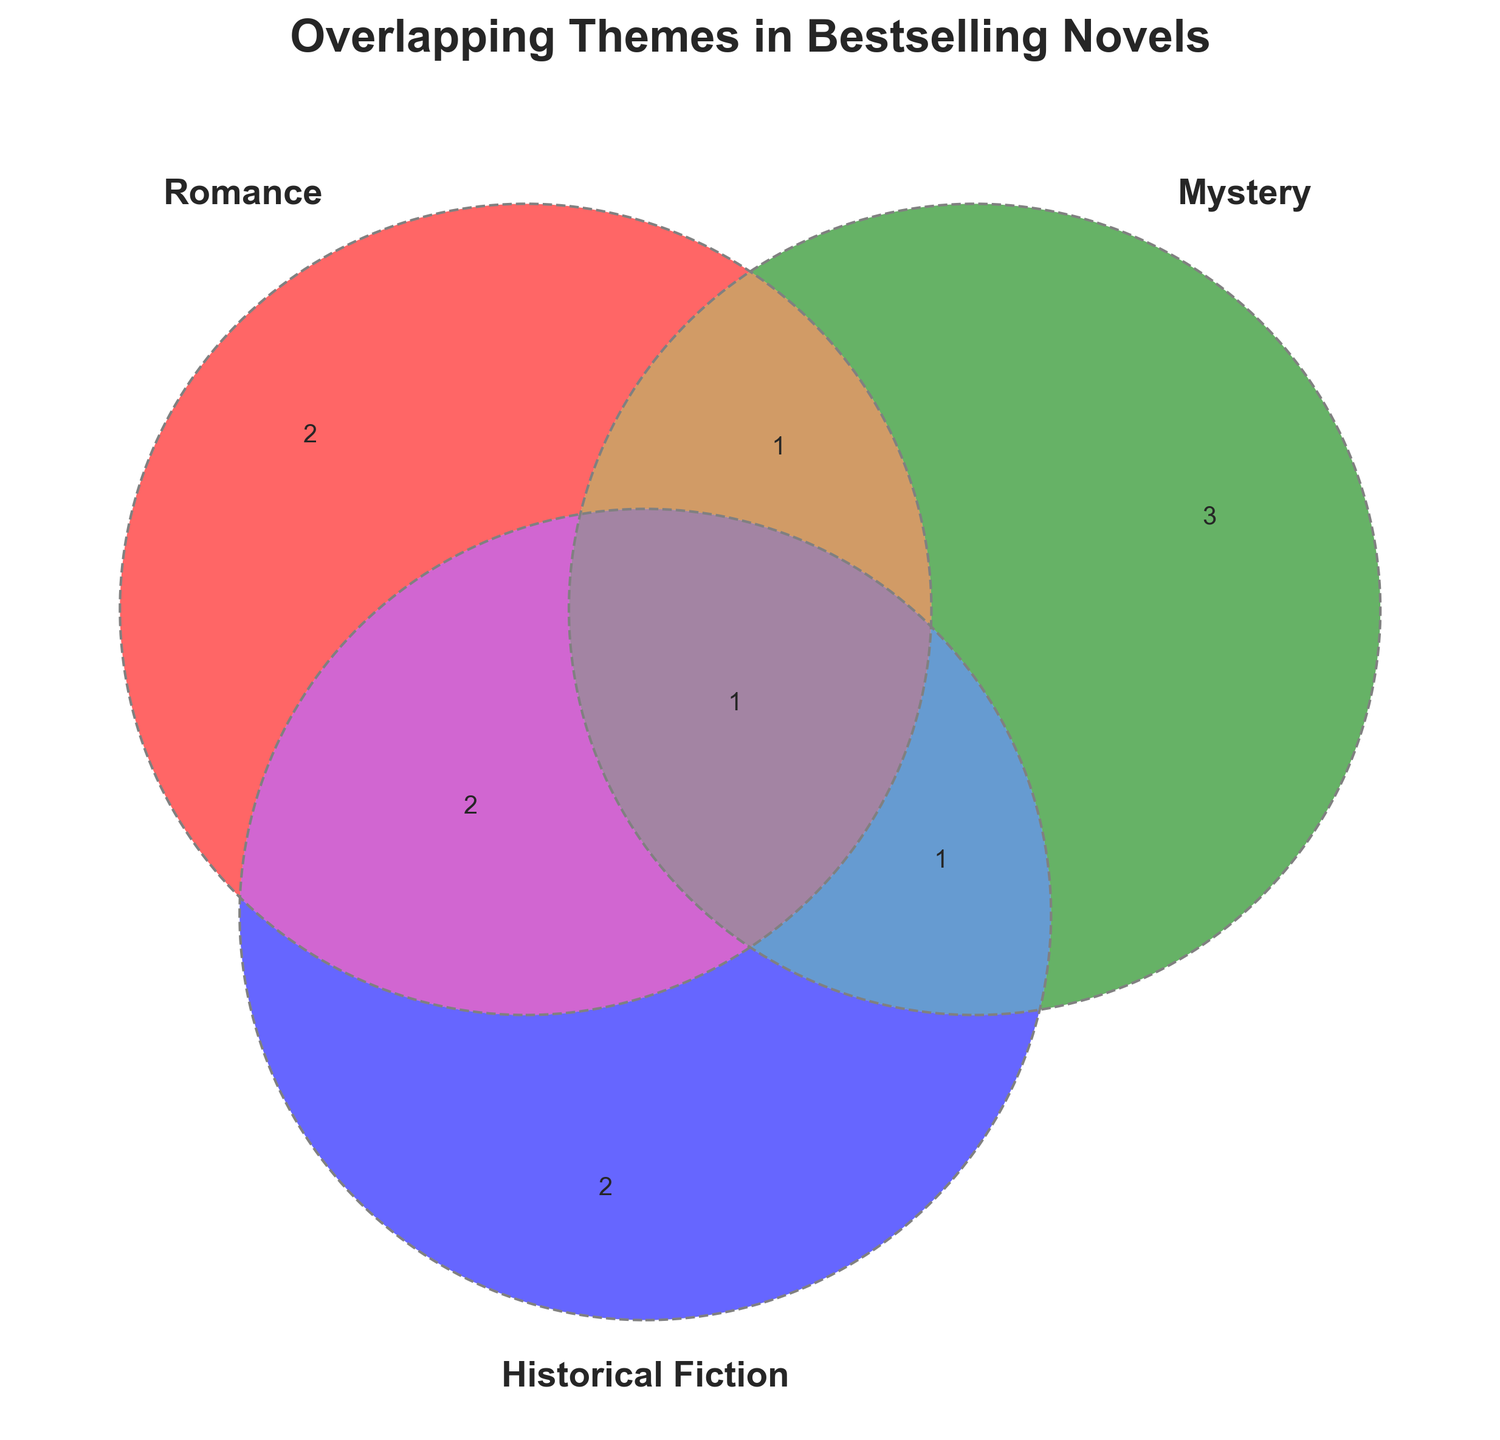What theme is common to all three genres? Family secrets is the only theme that appears in Romance, Mystery, and Historical Fiction. Hence, it is common to all three genres.
Answer: Family secrets Which themes are exclusively found in Historical Fiction? By examining the intersection involving Historical Fiction and excluding overlaps with Romance and Mystery, we find Time period setting and Historical accuracy are unique to Historical Fiction.
Answer: Time period setting, Historical accuracy How many themes are shared only between Romance and Mystery genres? Looking at the region where Romance and Mystery circles overlap but do not include Historical Fiction, we see only Love interest, making one shared theme.
Answer: 1 What theme appears in both Mystery and Historical Fiction but not in Romance? From the Venn Diagram, identify the overlap between Mystery and Historical Fiction while excluding Romance; the theme Plot twists fits this description.
Answer: Plot twists Does the theme "Character development" appear in Mystery novels? We see that "Character development" is not listed within the Mystery circle in the Venn Diagram. Therefore, it does not appear in Mystery novels.
Answer: No Compare the number of themes unique to Romance versus Historical Fiction. Which has more? Count the themes unique to Romance (Love interest, Emotional journey, Romantic tension, Personal growth) and Historical Fiction (Time period setting, Historical accuracy). Romance has 4 themes, while Historical Fiction has 2.
Answer: Romance Which themes are common between Romance and Historical Fiction but not appearing in Mystery? The overlap between Romance and Historical Fiction circles while excluding Mystery reveals Character development and Personal growth.
Answer: Character development, Personal growth 